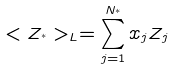Convert formula to latex. <formula><loc_0><loc_0><loc_500><loc_500>< Z _ { ^ { * } } > _ { L } = \sum _ { j = 1 } ^ { N _ { ^ { * } } } x _ { j } Z _ { j }</formula> 